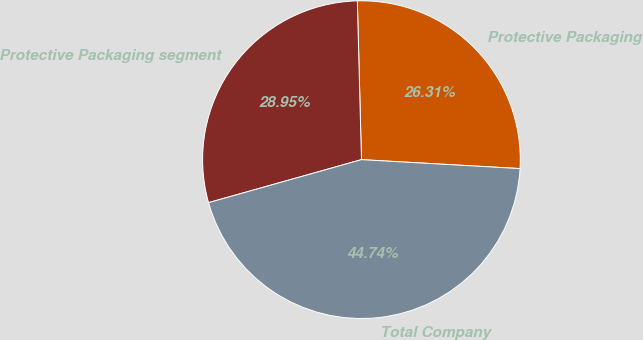Convert chart to OTSL. <chart><loc_0><loc_0><loc_500><loc_500><pie_chart><fcel>Protective Packaging<fcel>Protective Packaging segment<fcel>Total Company<nl><fcel>26.31%<fcel>28.95%<fcel>44.74%<nl></chart> 